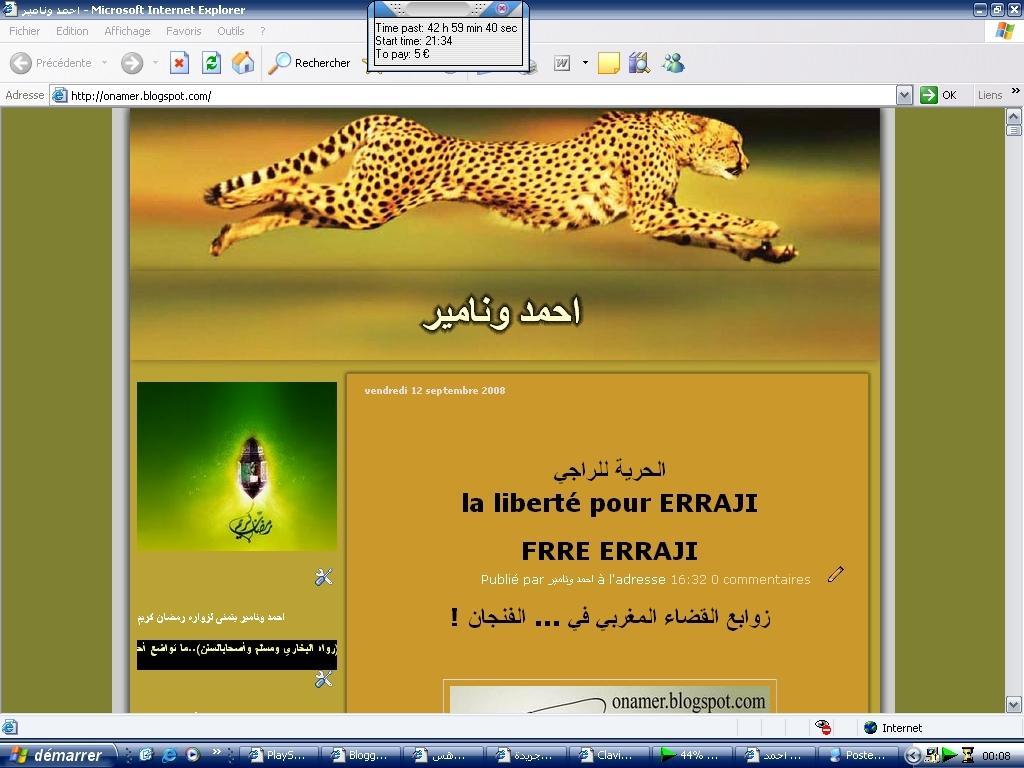In one or two sentences, can you explain what this image depicts? This image consists of a screenshot of a computer. In which we can see a cheetah and the text. 